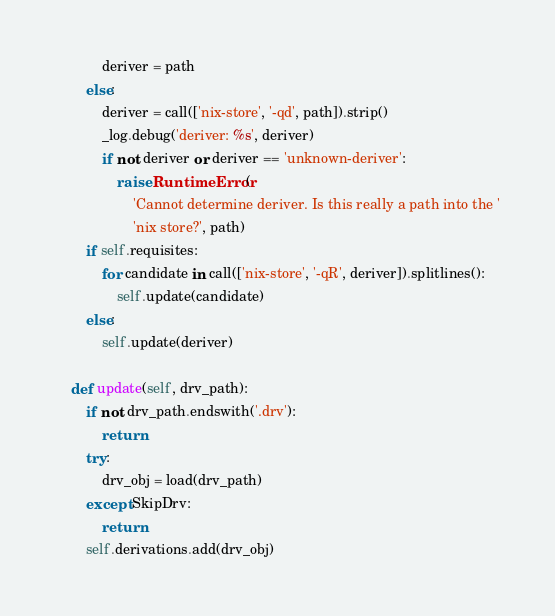Convert code to text. <code><loc_0><loc_0><loc_500><loc_500><_Python_>            deriver = path
        else:
            deriver = call(['nix-store', '-qd', path]).strip()
            _log.debug('deriver: %s', deriver)
            if not deriver or deriver == 'unknown-deriver':
                raise RuntimeError(
                    'Cannot determine deriver. Is this really a path into the '
                    'nix store?', path)
        if self.requisites:
            for candidate in call(['nix-store', '-qR', deriver]).splitlines():
                self.update(candidate)
        else:
            self.update(deriver)

    def update(self, drv_path):
        if not drv_path.endswith('.drv'):
            return
        try:
            drv_obj = load(drv_path)
        except SkipDrv:
            return
        self.derivations.add(drv_obj)
</code> 